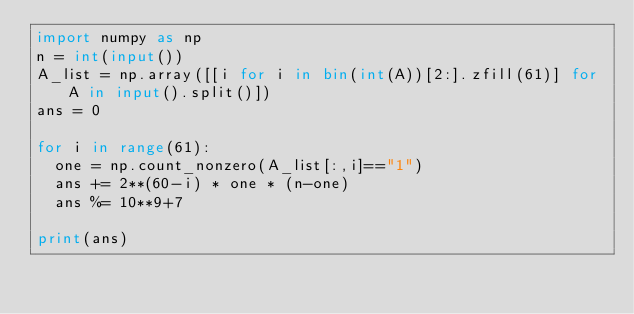<code> <loc_0><loc_0><loc_500><loc_500><_Python_>import numpy as np
n = int(input())
A_list = np.array([[i for i in bin(int(A))[2:].zfill(61)] for A in input().split()])
ans = 0

for i in range(61):
  one = np.count_nonzero(A_list[:,i]=="1")
  ans += 2**(60-i) * one * (n-one)
  ans %= 10**9+7

print(ans)</code> 